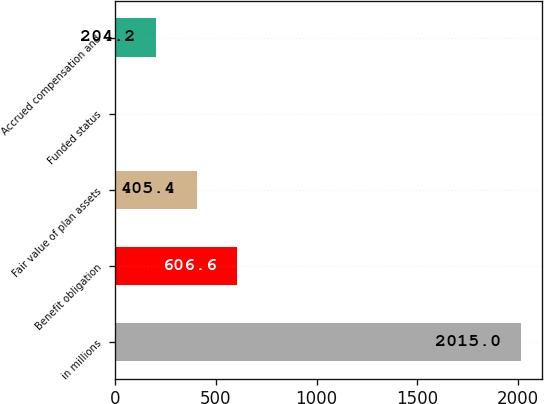Convert chart to OTSL. <chart><loc_0><loc_0><loc_500><loc_500><bar_chart><fcel>in millions<fcel>Benefit obligation<fcel>Fair value of plan assets<fcel>Funded status<fcel>Accrued compensation and<nl><fcel>2015<fcel>606.6<fcel>405.4<fcel>3<fcel>204.2<nl></chart> 